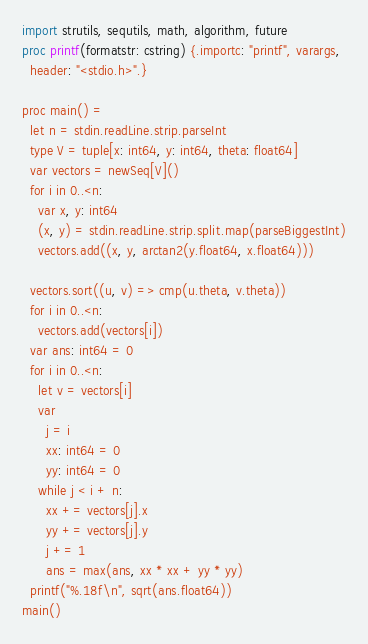<code> <loc_0><loc_0><loc_500><loc_500><_Nim_>import strutils, sequtils, math, algorithm, future
proc printf(formatstr: cstring) {.importc: "printf", varargs,
  header: "<stdio.h>".}

proc main() =
  let n = stdin.readLine.strip.parseInt
  type V = tuple[x: int64, y: int64, theta: float64]
  var vectors = newSeq[V]()
  for i in 0..<n:
    var x, y: int64
    (x, y) = stdin.readLine.strip.split.map(parseBiggestInt)
    vectors.add((x, y, arctan2(y.float64, x.float64)))

  vectors.sort((u, v) => cmp(u.theta, v.theta))
  for i in 0..<n:
    vectors.add(vectors[i])
  var ans: int64 = 0
  for i in 0..<n:
    let v = vectors[i]
    var
      j = i
      xx: int64 = 0
      yy: int64 = 0
    while j < i + n:
      xx += vectors[j].x
      yy += vectors[j].y
      j += 1
      ans = max(ans, xx * xx + yy * yy)
  printf("%.18f\n", sqrt(ans.float64))
main()
</code> 